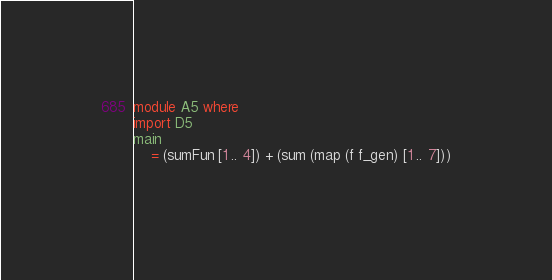Convert code to text. <code><loc_0><loc_0><loc_500><loc_500><_Haskell_>module A5 where
import D5
main
    = (sumFun [1 .. 4]) + (sum (map (f f_gen) [1 .. 7]))
 </code> 